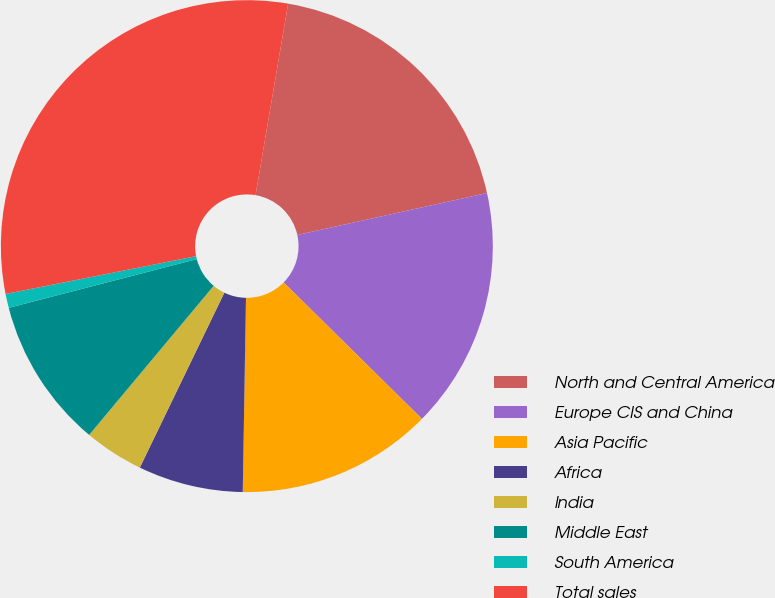Convert chart. <chart><loc_0><loc_0><loc_500><loc_500><pie_chart><fcel>North and Central America<fcel>Europe CIS and China<fcel>Asia Pacific<fcel>Africa<fcel>India<fcel>Middle East<fcel>South America<fcel>Total sales<nl><fcel>18.85%<fcel>15.86%<fcel>12.87%<fcel>6.9%<fcel>3.91%<fcel>9.89%<fcel>0.92%<fcel>30.8%<nl></chart> 